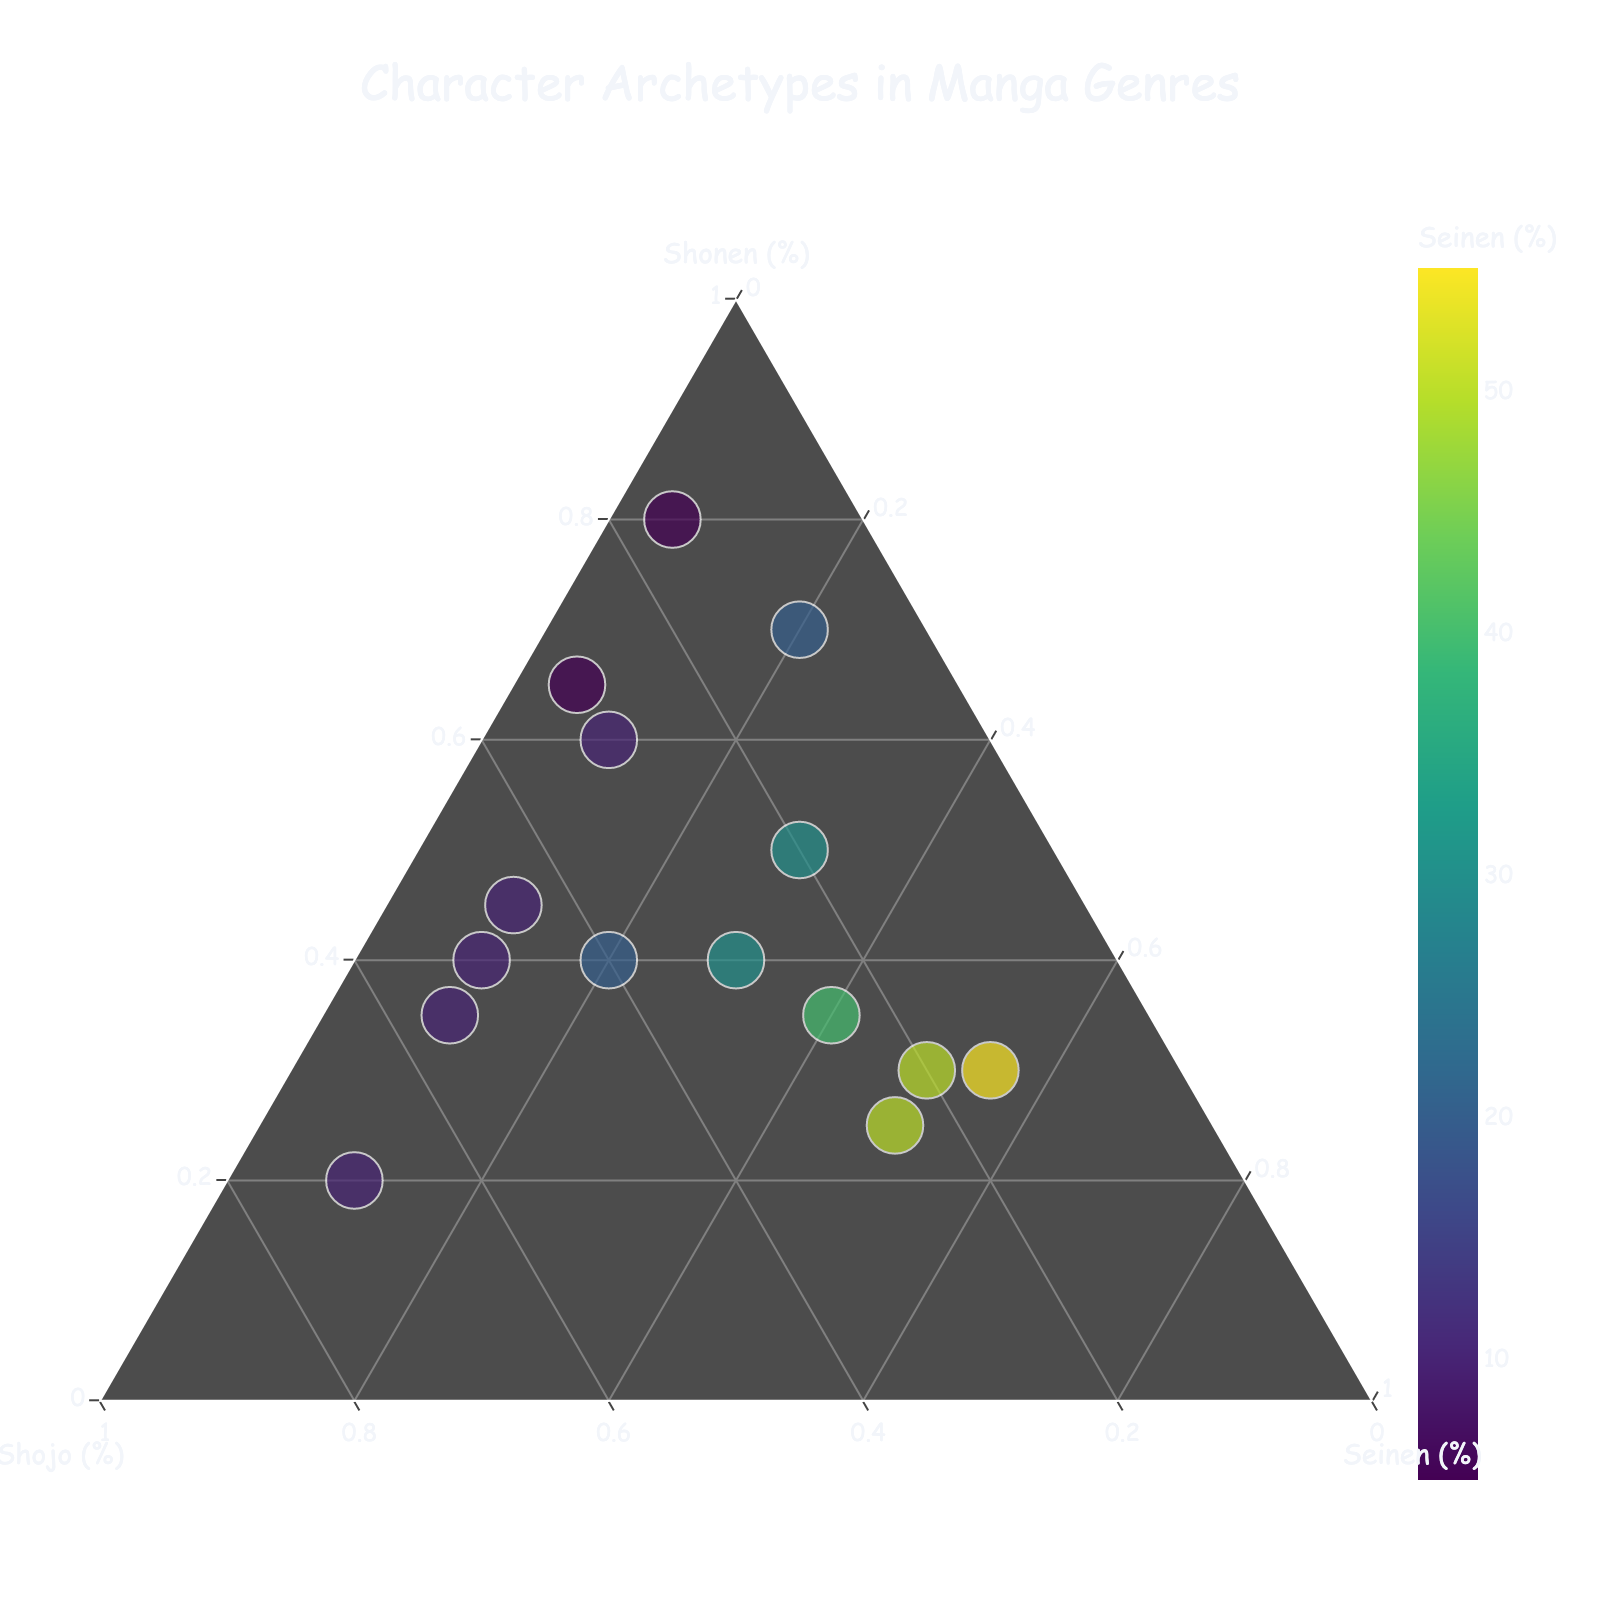What's the title of the figure? The title of the figure appears at the top and is often larger in font size compared to other text elements.
Answer: Character Archetypes in Manga Genres How many character archetypes are represented in the figure? Each data point represents a character archetype, count each one to find the total.
Answer: 15 Which character archetype is the most dominant in Shonen manga? Look for the data point closest to the Shonen apex (top vertex) of the ternary plot.
Answer: Determined Underdog Which character archetype has the highest balance between Shonen and Shojo, excluding Seinen? Look for character archetypes near the Shonen-Shojo edge (left side) of the ternary plot with minimal presence towards the Seinen vertex.
Answer: Tsundere Rival Which character has a higher Seinen percentage, the Brooding Antihero or the Eccentric Genius? Compare the y-coordinates on the c-axis (Seinen) for both data points.
Answer: Eccentric Genius What is the median Shojo percentage among all character archetypes? List the Shojo percentages, order them, and find the middle value. (10, 10, 10, 10, 15, 15, 20, 20, 20, 25, 25, 30, 30, 40, 45, 50, 55, 55, 70)
Answer: 25 Which character archetype has a nearly equal distribution across Shonen, Shojo, and Seinen? Look for data points near the center of the ternary plot where shares of all three genres are balanced.
Answer: Wise Mentor What percentage of Shonen does the Energetic Mascot character archetype represent? Find the Energetic Mascot data point and look at its Shonen value (x-axis).
Answer: 65% Between the Gentle Giant and Protective Older Sibling, which has more representation in Shojo manga? Compare the percentages of the Shojo value for both characters.
Answer: Protective Older Sibling Is there a character archetype that is predominantly featured in Seinen manga? If yes, name it. Look for data points that are closest to the Seinen vertex (right-bottom).
Answer: Complex Villain 